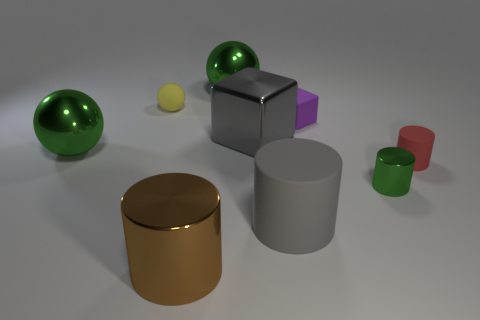Subtract all gray cylinders. How many cylinders are left? 3 Subtract all brown cylinders. How many cylinders are left? 3 Subtract all yellow cylinders. Subtract all yellow balls. How many cylinders are left? 4 Add 1 red rubber cylinders. How many objects exist? 10 Subtract all spheres. How many objects are left? 6 Subtract 0 gray spheres. How many objects are left? 9 Subtract all tiny cyan cylinders. Subtract all shiny cylinders. How many objects are left? 7 Add 9 big shiny cylinders. How many big shiny cylinders are left? 10 Add 2 small purple shiny balls. How many small purple shiny balls exist? 2 